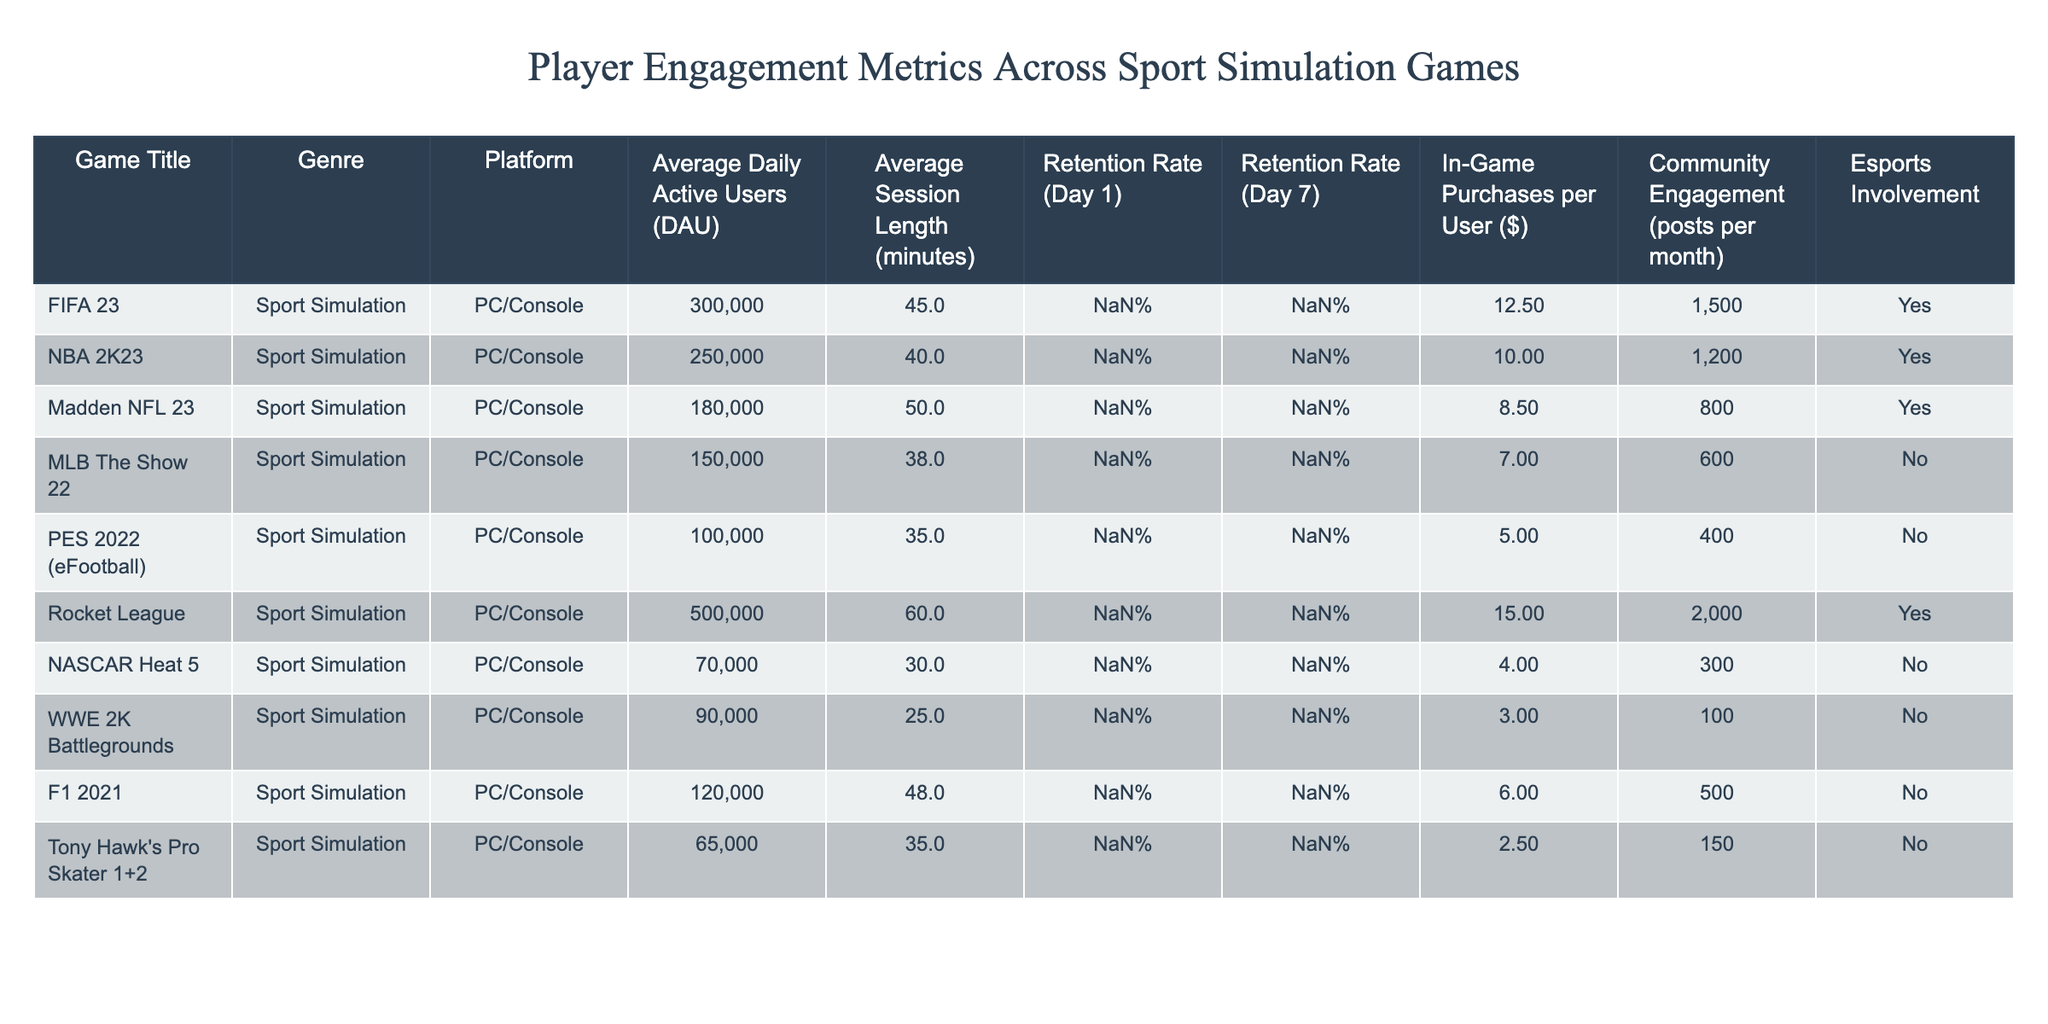What is the Average Daily Active Users (DAU) for Rocket League? The table shows that Rocket League has an Average Daily Active Users (DAU) of 500,000.
Answer: 500,000 Which game has the highest Average Session Length? By examining the Average Session Length column, Rocket League has the highest value at 60 minutes compared to the other games.
Answer: 60 minutes What is the Retention Rate (Day 1) for NBA 2K23? The table indicates that NBA 2K23 has a Retention Rate (Day 1) of 50%.
Answer: 50% How many in-game purchases per user does WWE 2K Battlegrounds have compared to PES 2022? WWE 2K Battlegrounds has 3.00 in-game purchases per user while PES 2022 has 5.00. Therefore, PES 2022 has 2.00 more in-game purchases per user than WWE 2K Battlegrounds.
Answer: PES 2022 has 2.00 more Which game has a lower retention rate on Day 7, NASCAR Heat 5 or MLB The Show 22? NASCAR Heat 5 has a Day 7 retention rate of 12%, while MLB The Show 22 has 18%. Hence, NASCAR Heat 5 has a lower retention rate.
Answer: NASCAR Heat 5 Calculate the average in-game purchases per user across all the listed games. The total in-game purchases across all games are 12.50 + 10.00 + 8.50 + 7.00 + 5.00 + 15.00 + 4.00 + 3.00 + 6.00 + 2.50 = 73.50. With 10 games total, the average is 73.50 / 10 = 7.35.
Answer: 7.35 Is the community engagement for Madden NFL 23 greater than the community engagement for F1 2021? Madden NFL 23 has community engagement of 800 posts per month, while F1 2021 has 500 posts per month. Thus, Madden NFL 23 has greater community engagement.
Answer: Yes Which two games have an esports involvement of "Yes"? The table shows that FIFA 23 and Rocket League both have "Yes" listed under Esports Involvement.
Answer: FIFA 23 and Rocket League Identify the game with the lowest Retention Rate (Day 1). Upon comparison, Tony Hawk's Pro Skater 1+2 has the lowest Retention Rate (Day 1) at 33%.
Answer: Tony Hawk's Pro Skater 1+2 Does the average session length of PES 2022 exceed 30 minutes? The Average Session Length for PES 2022 is 35 minutes, which does exceed 30 minutes.
Answer: Yes What is the difference in Average Daily Active Users (DAU) between FIFA 23 and Madden NFL 23? FIFA 23 has 300,000 DAU while Madden NFL 23 has 180,000 DAU. The difference is 300,000 - 180,000 = 120,000.
Answer: 120,000 